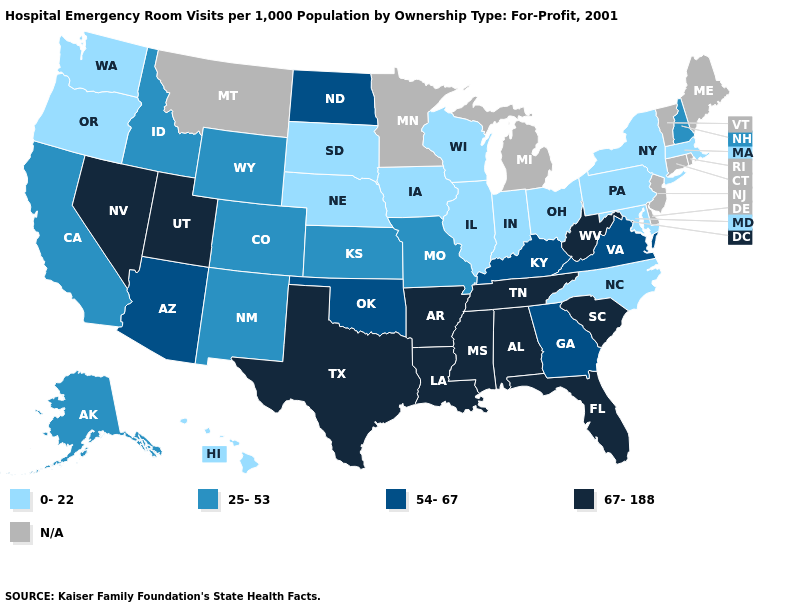Does the map have missing data?
Keep it brief. Yes. What is the value of New York?
Short answer required. 0-22. Name the states that have a value in the range 67-188?
Be succinct. Alabama, Arkansas, Florida, Louisiana, Mississippi, Nevada, South Carolina, Tennessee, Texas, Utah, West Virginia. Name the states that have a value in the range 54-67?
Quick response, please. Arizona, Georgia, Kentucky, North Dakota, Oklahoma, Virginia. Does the first symbol in the legend represent the smallest category?
Be succinct. Yes. What is the lowest value in the Northeast?
Be succinct. 0-22. What is the value of Nevada?
Concise answer only. 67-188. Which states have the highest value in the USA?
Write a very short answer. Alabama, Arkansas, Florida, Louisiana, Mississippi, Nevada, South Carolina, Tennessee, Texas, Utah, West Virginia. Among the states that border Oregon , does Washington have the lowest value?
Give a very brief answer. Yes. Is the legend a continuous bar?
Be succinct. No. What is the highest value in the USA?
Short answer required. 67-188. Name the states that have a value in the range 54-67?
Give a very brief answer. Arizona, Georgia, Kentucky, North Dakota, Oklahoma, Virginia. Among the states that border Washington , which have the highest value?
Answer briefly. Idaho. Name the states that have a value in the range 54-67?
Be succinct. Arizona, Georgia, Kentucky, North Dakota, Oklahoma, Virginia. 